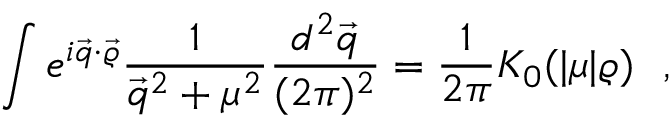Convert formula to latex. <formula><loc_0><loc_0><loc_500><loc_500>\int e ^ { i \vec { q } \cdot \vec { \varrho } } \frac { 1 } { \vec { q } ^ { 2 } + \mu ^ { 2 } } \frac { d ^ { 2 } \vec { q } } { ( 2 \pi ) ^ { 2 } } = \frac { 1 } { 2 \pi } K _ { 0 } ( | \mu | \varrho ) ,</formula> 